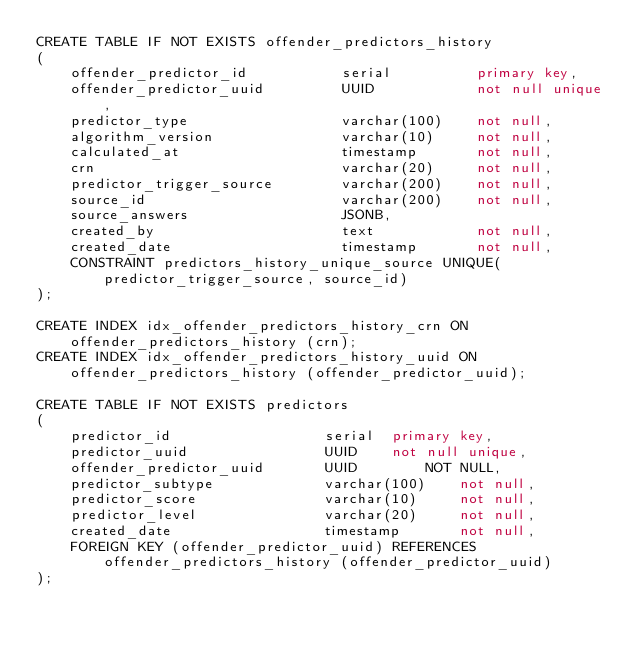Convert code to text. <code><loc_0><loc_0><loc_500><loc_500><_SQL_>CREATE TABLE IF NOT EXISTS offender_predictors_history
(
    offender_predictor_id           serial          primary key,
    offender_predictor_uuid         UUID            not null unique,
    predictor_type                  varchar(100)    not null,
    algorithm_version               varchar(10)     not null,
    calculated_at                   timestamp       not null,
    crn                             varchar(20)     not null,
    predictor_trigger_source        varchar(200)    not null,
    source_id                       varchar(200)    not null,
    source_answers                  JSONB,
    created_by                      text            not null,
    created_date                    timestamp       not null,
    CONSTRAINT predictors_history_unique_source UNIQUE(predictor_trigger_source, source_id)
);

CREATE INDEX idx_offender_predictors_history_crn ON offender_predictors_history (crn);
CREATE INDEX idx_offender_predictors_history_uuid ON offender_predictors_history (offender_predictor_uuid);

CREATE TABLE IF NOT EXISTS predictors
(
    predictor_id                  serial  primary key,
    predictor_uuid                UUID    not null unique,
    offender_predictor_uuid       UUID        NOT NULL,
    predictor_subtype             varchar(100)    not null,
    predictor_score               varchar(10)     not null,
    predictor_level               varchar(20)     not null,
    created_date                  timestamp       not null,
    FOREIGN KEY (offender_predictor_uuid) REFERENCES offender_predictors_history (offender_predictor_uuid)
);
</code> 